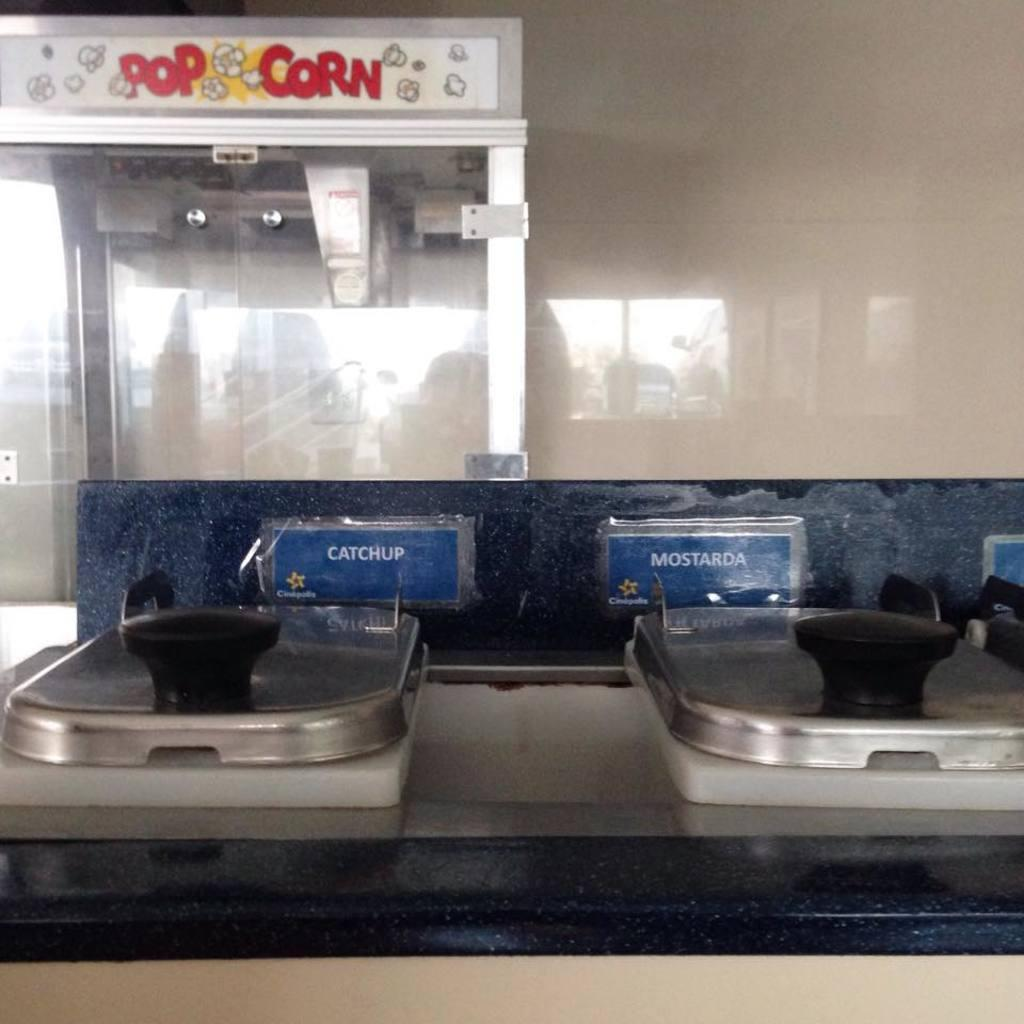<image>
Describe the image concisely. A popcorn machine in front of a condiment station 